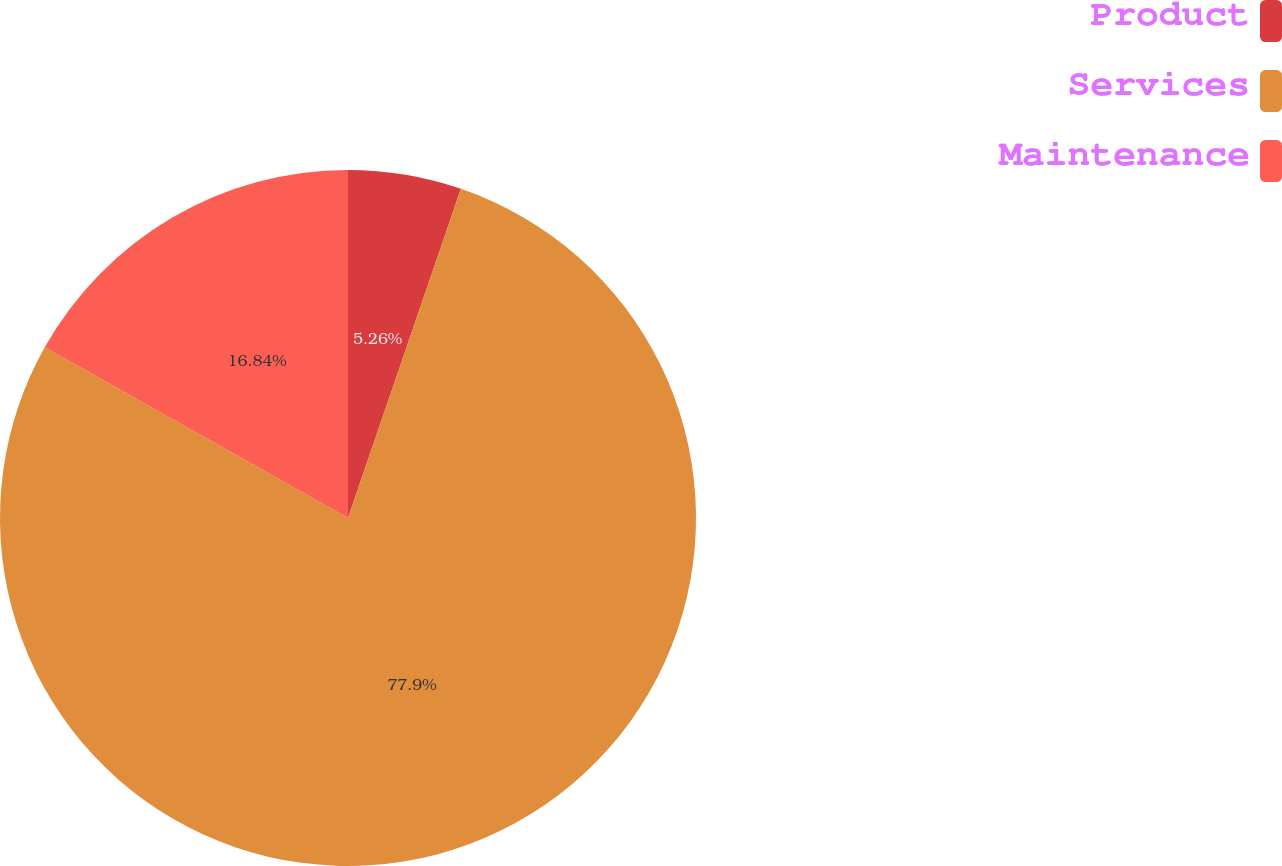<chart> <loc_0><loc_0><loc_500><loc_500><pie_chart><fcel>Product<fcel>Services<fcel>Maintenance<nl><fcel>5.26%<fcel>77.89%<fcel>16.84%<nl></chart> 